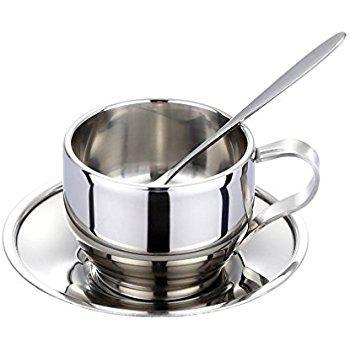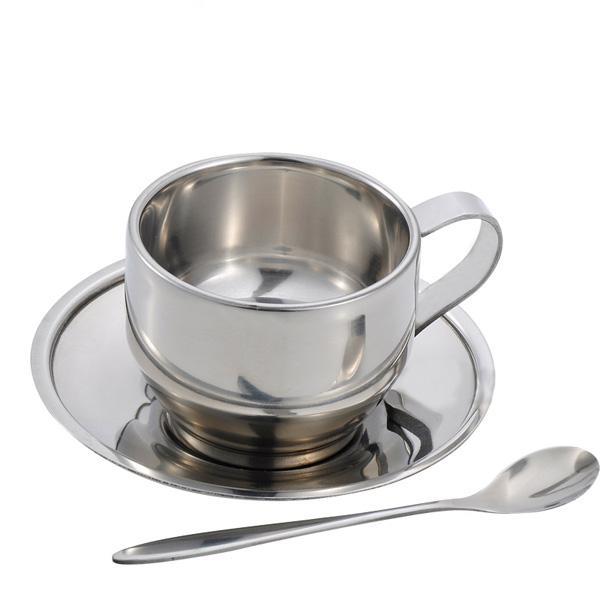The first image is the image on the left, the second image is the image on the right. For the images displayed, is the sentence "The spoon is in the cup in the image on the right." factually correct? Answer yes or no. No. 